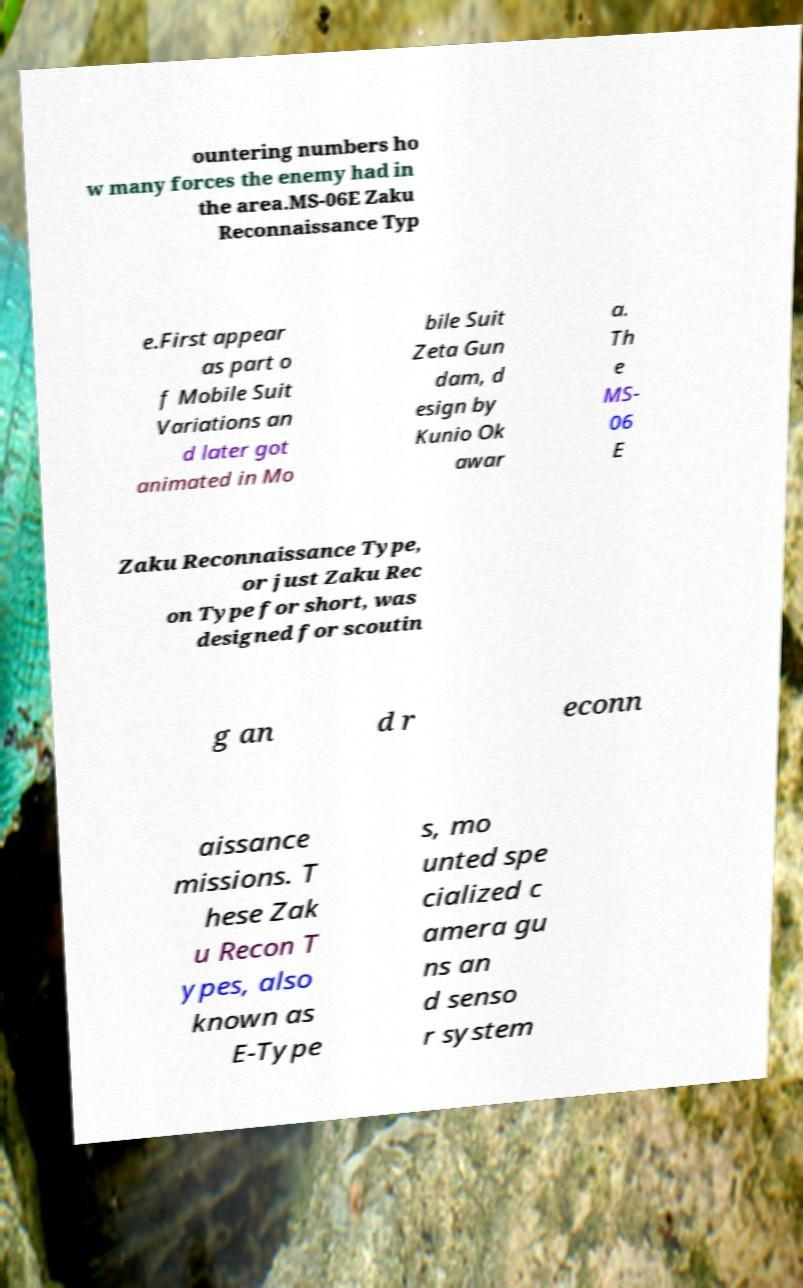Can you read and provide the text displayed in the image?This photo seems to have some interesting text. Can you extract and type it out for me? ountering numbers ho w many forces the enemy had in the area.MS-06E Zaku Reconnaissance Typ e.First appear as part o f Mobile Suit Variations an d later got animated in Mo bile Suit Zeta Gun dam, d esign by Kunio Ok awar a. Th e MS- 06 E Zaku Reconnaissance Type, or just Zaku Rec on Type for short, was designed for scoutin g an d r econn aissance missions. T hese Zak u Recon T ypes, also known as E-Type s, mo unted spe cialized c amera gu ns an d senso r system 